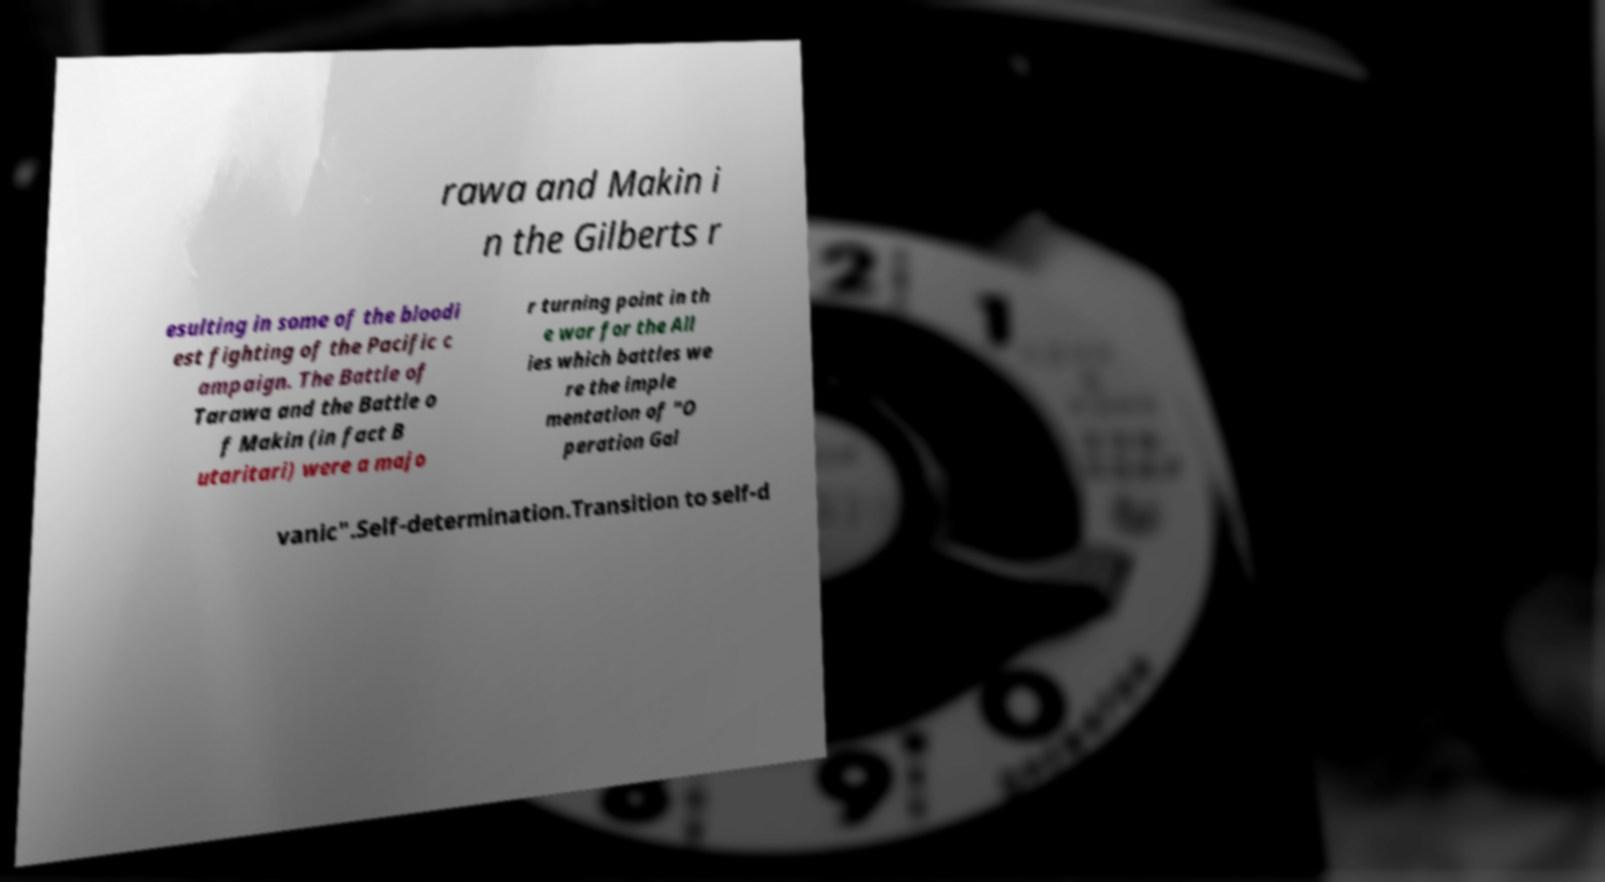Could you assist in decoding the text presented in this image and type it out clearly? rawa and Makin i n the Gilberts r esulting in some of the bloodi est fighting of the Pacific c ampaign. The Battle of Tarawa and the Battle o f Makin (in fact B utaritari) were a majo r turning point in th e war for the All ies which battles we re the imple mentation of "O peration Gal vanic".Self-determination.Transition to self-d 